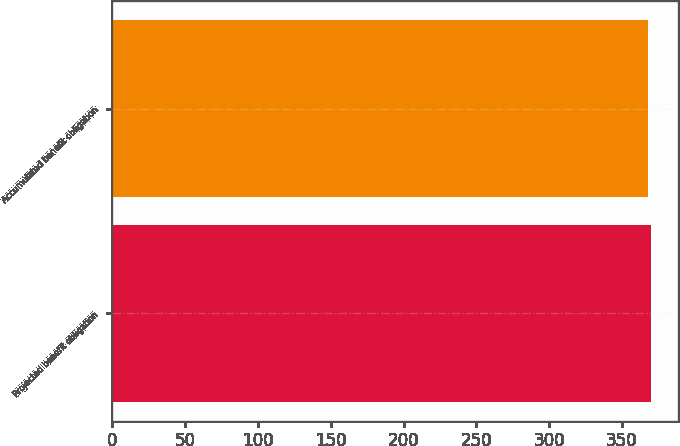Convert chart. <chart><loc_0><loc_0><loc_500><loc_500><bar_chart><fcel>Projected benefit obligation<fcel>Accumulated benefit obligation<nl><fcel>370<fcel>368<nl></chart> 